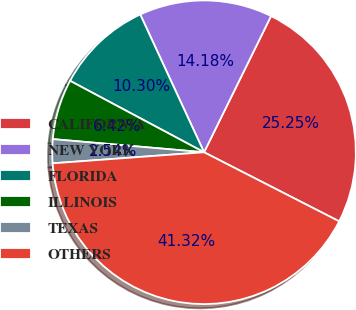Convert chart to OTSL. <chart><loc_0><loc_0><loc_500><loc_500><pie_chart><fcel>CALIFORNIA<fcel>NEW YORK<fcel>FLORIDA<fcel>ILLINOIS<fcel>TEXAS<fcel>OTHERS<nl><fcel>25.25%<fcel>14.18%<fcel>10.3%<fcel>6.42%<fcel>2.54%<fcel>41.32%<nl></chart> 